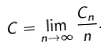Convert formula to latex. <formula><loc_0><loc_0><loc_500><loc_500>C = \lim _ { n \rightarrow \infty } \frac { C _ { n } } { n } .</formula> 